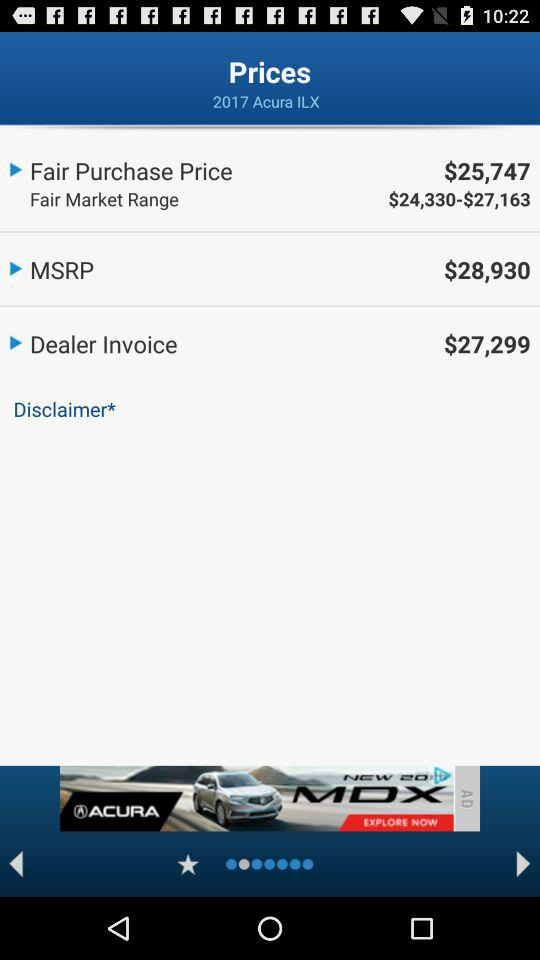What is the difference between the MSRP and the Dealer Invoice?
Answer the question using a single word or phrase. $1,631 